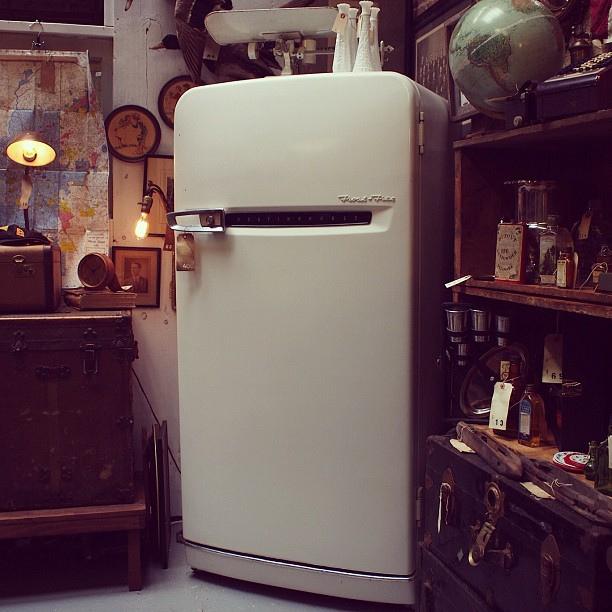Is this a modern fridge?
Short answer required. No. What color is the fridge door?
Quick response, please. White. Was this picture taken inside someone's home?
Write a very short answer. Yes. 